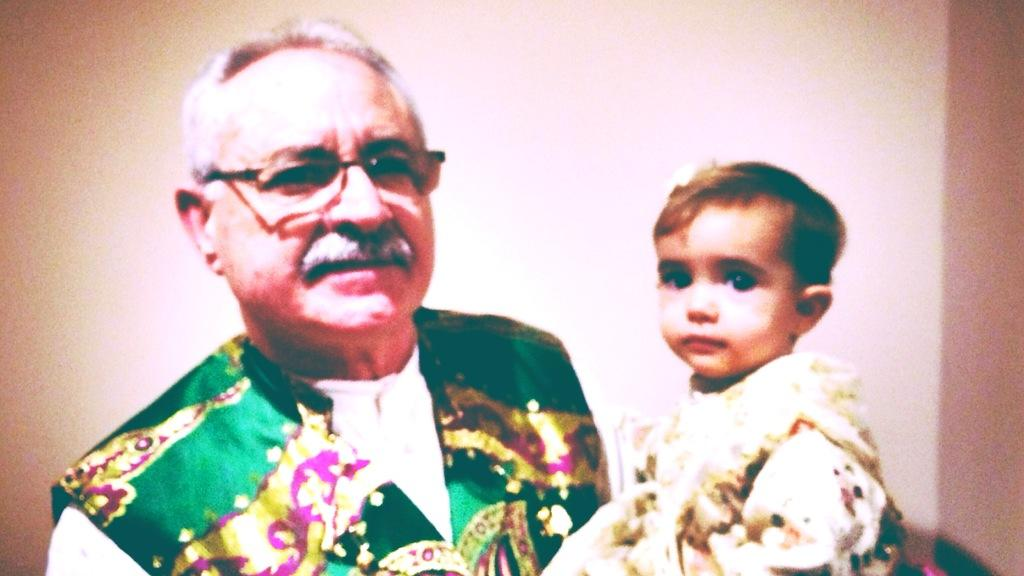What is present in the image? There is a poster in the image. What is depicted on the poster? The poster contains two people. What type of cave can be seen in the background of the poster? There is no cave present in the image, as it only features a poster with two people. 